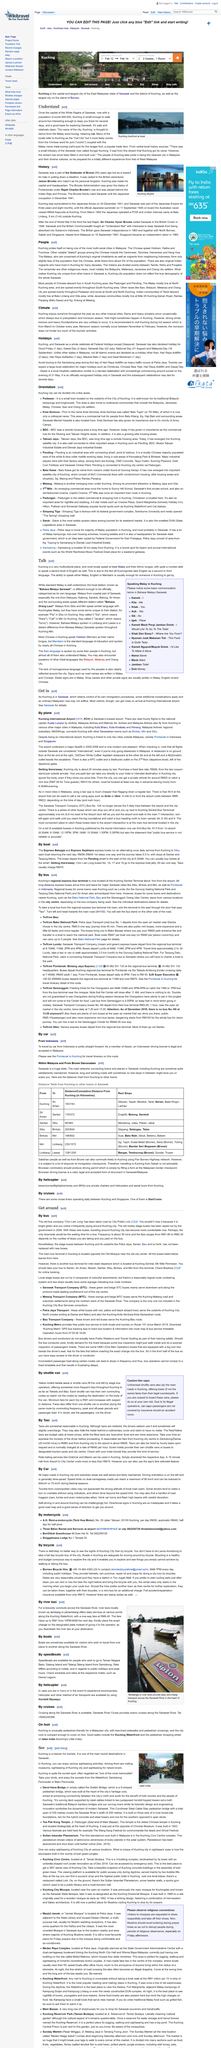List a handful of essential elements in this visual. Kuching is one of the main tourist destinations in Sarawak, which is also considered as a tourist attraction. Kuching's regional express bus terminal is located at Kuching Sentral Terminal, which is approximately 1km from the airport. Kuching is commonly referred to as Cat City by many of the locals. The main bus terminal in Kuching can be found opposite the Old Mosque in a location near the old city center. The city being discussed in the article is Kuching. 